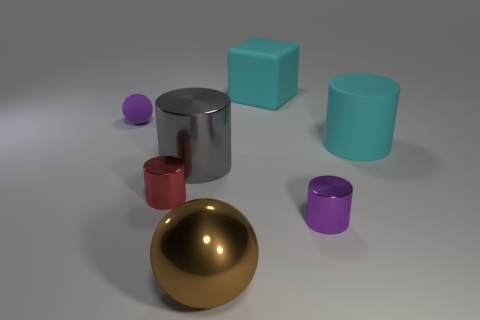The gray thing that is the same material as the large ball is what shape?
Your response must be concise. Cylinder. Are there fewer large brown balls than tiny green things?
Your answer should be very brief. No. Is the material of the red object the same as the purple cylinder?
Ensure brevity in your answer.  Yes. How many other things are there of the same color as the matte sphere?
Your answer should be very brief. 1. Is the number of small green cylinders greater than the number of gray cylinders?
Offer a very short reply. No. There is a red metal object; does it have the same size as the cyan matte object in front of the purple rubber thing?
Ensure brevity in your answer.  No. There is a tiny metallic cylinder that is left of the block; what is its color?
Make the answer very short. Red. How many brown objects are large cylinders or metal objects?
Provide a succinct answer. 1. What color is the cube?
Give a very brief answer. Cyan. Are there any other things that have the same material as the gray thing?
Keep it short and to the point. Yes. 